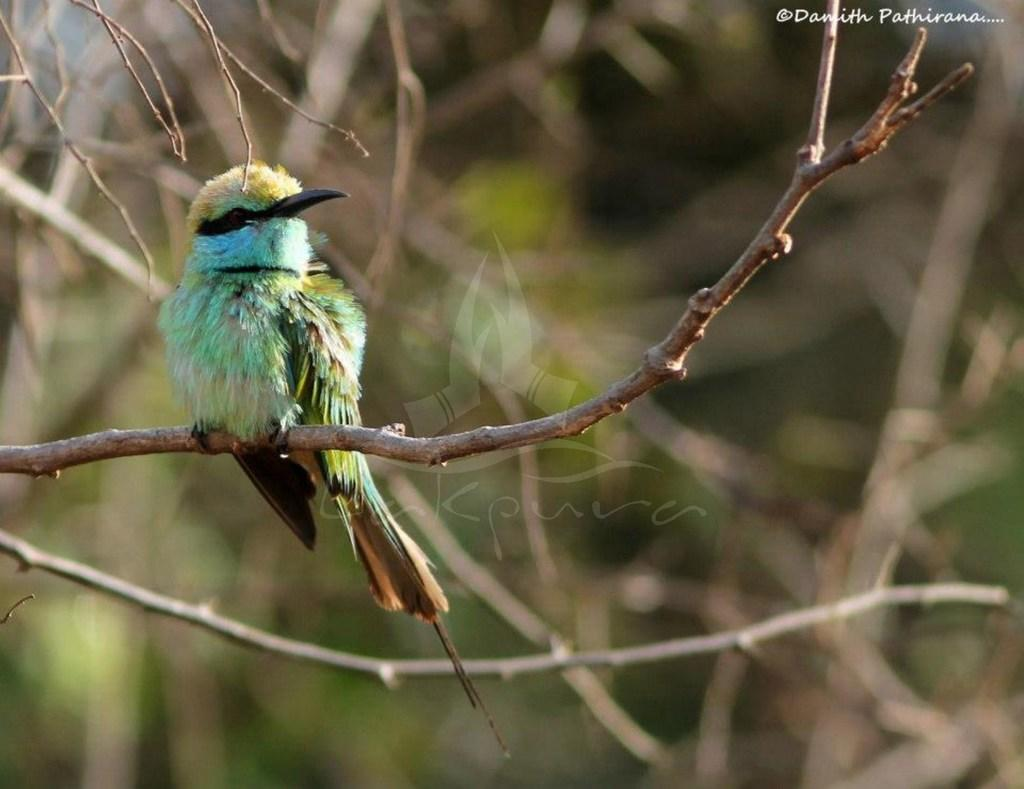What is the main subject of the image? There is a bird on a branch in the center of the image. Can you describe any additional features or elements in the image? There is a watermark on the right top of the image. What can be seen in the background of the image? There are trees visible in the background of the image. How much money is being exchanged between the birds in the image? There are no birds exchanging money in the image; it features a single bird on a branch. What type of heat source is visible in the image? There is no heat source visible in the image; it primarily features a bird and trees. 